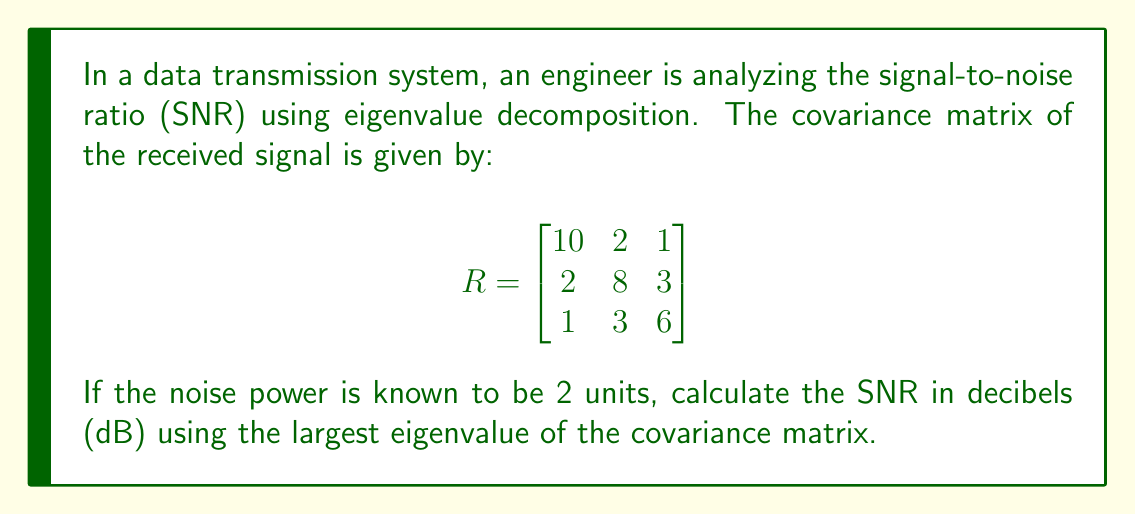Help me with this question. To solve this problem, we'll follow these steps:

1. Find the eigenvalues of the covariance matrix R.
2. Identify the largest eigenvalue.
3. Calculate the SNR using the largest eigenvalue and the given noise power.
4. Convert the SNR to decibels.

Step 1: Find the eigenvalues of R
To find the eigenvalues, we need to solve the characteristic equation:
$$\det(R - \lambda I) = 0$$

Expanding this determinant:
$$\begin{vmatrix}
10-\lambda & 2 & 1 \\
2 & 8-\lambda & 3 \\
1 & 3 & 6-\lambda
\end{vmatrix} = 0$$

This leads to the characteristic polynomial:
$$-\lambda^3 + 24\lambda^2 - 167\lambda + 336 = 0$$

Solving this equation (using a calculator or computer algebra system) gives us the eigenvalues:
$$\lambda_1 \approx 14.54, \lambda_2 \approx 7.54, \lambda_3 \approx 1.92$$

Step 2: Identify the largest eigenvalue
The largest eigenvalue is $\lambda_1 \approx 14.54$.

Step 3: Calculate the SNR
The signal power is represented by the largest eigenvalue, and we're given the noise power. The SNR is the ratio of signal power to noise power:

$$SNR = \frac{\text{Signal Power}}{\text{Noise Power}} = \frac{14.54}{2} = 7.27$$

Step 4: Convert to decibels
The formula to convert SNR to decibels is:
$$SNR_{dB} = 10 \log_{10}(SNR)$$

Substituting our value:
$$SNR_{dB} = 10 \log_{10}(7.27) \approx 8.61 \text{ dB}$$
Answer: The signal-to-noise ratio (SNR) is approximately 8.61 dB. 